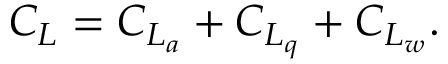<formula> <loc_0><loc_0><loc_500><loc_500>\begin{array} { r } { C _ { L } = C _ { L _ { a } } + C _ { L _ { q } } + C _ { L _ { w } } . } \end{array}</formula> 